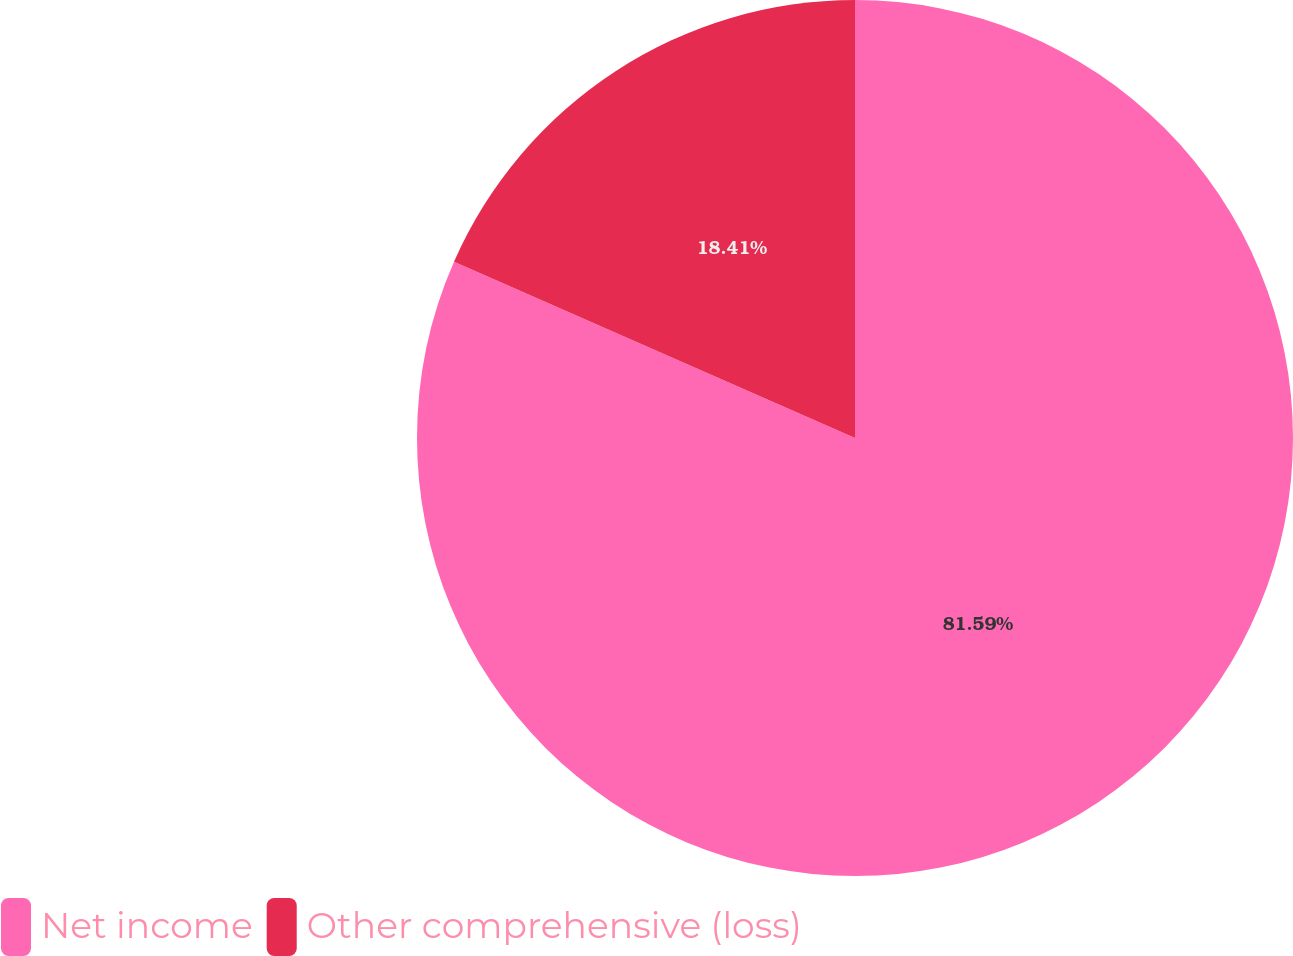<chart> <loc_0><loc_0><loc_500><loc_500><pie_chart><fcel>Net income<fcel>Other comprehensive (loss)<nl><fcel>81.59%<fcel>18.41%<nl></chart> 